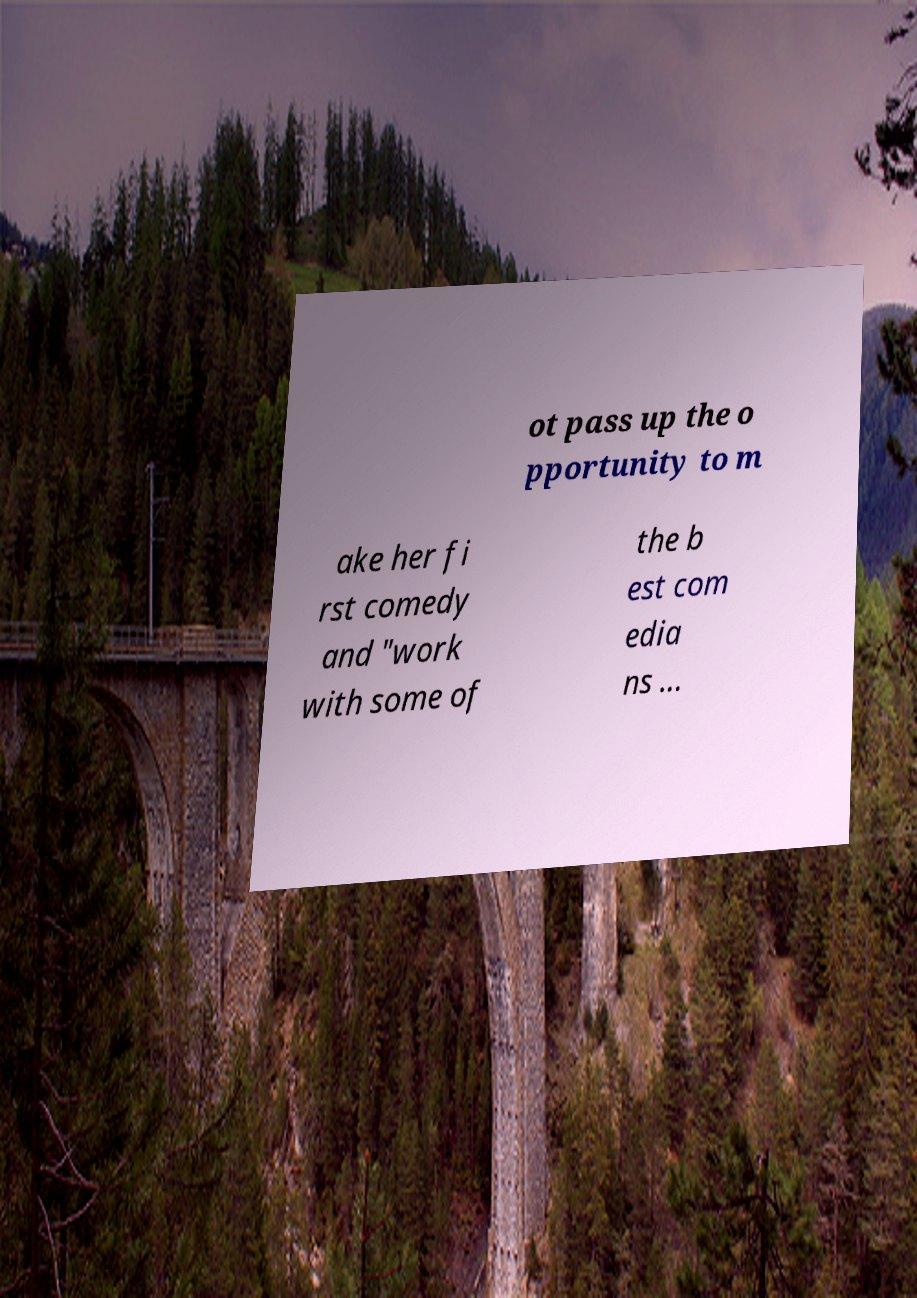Could you extract and type out the text from this image? ot pass up the o pportunity to m ake her fi rst comedy and "work with some of the b est com edia ns ... 